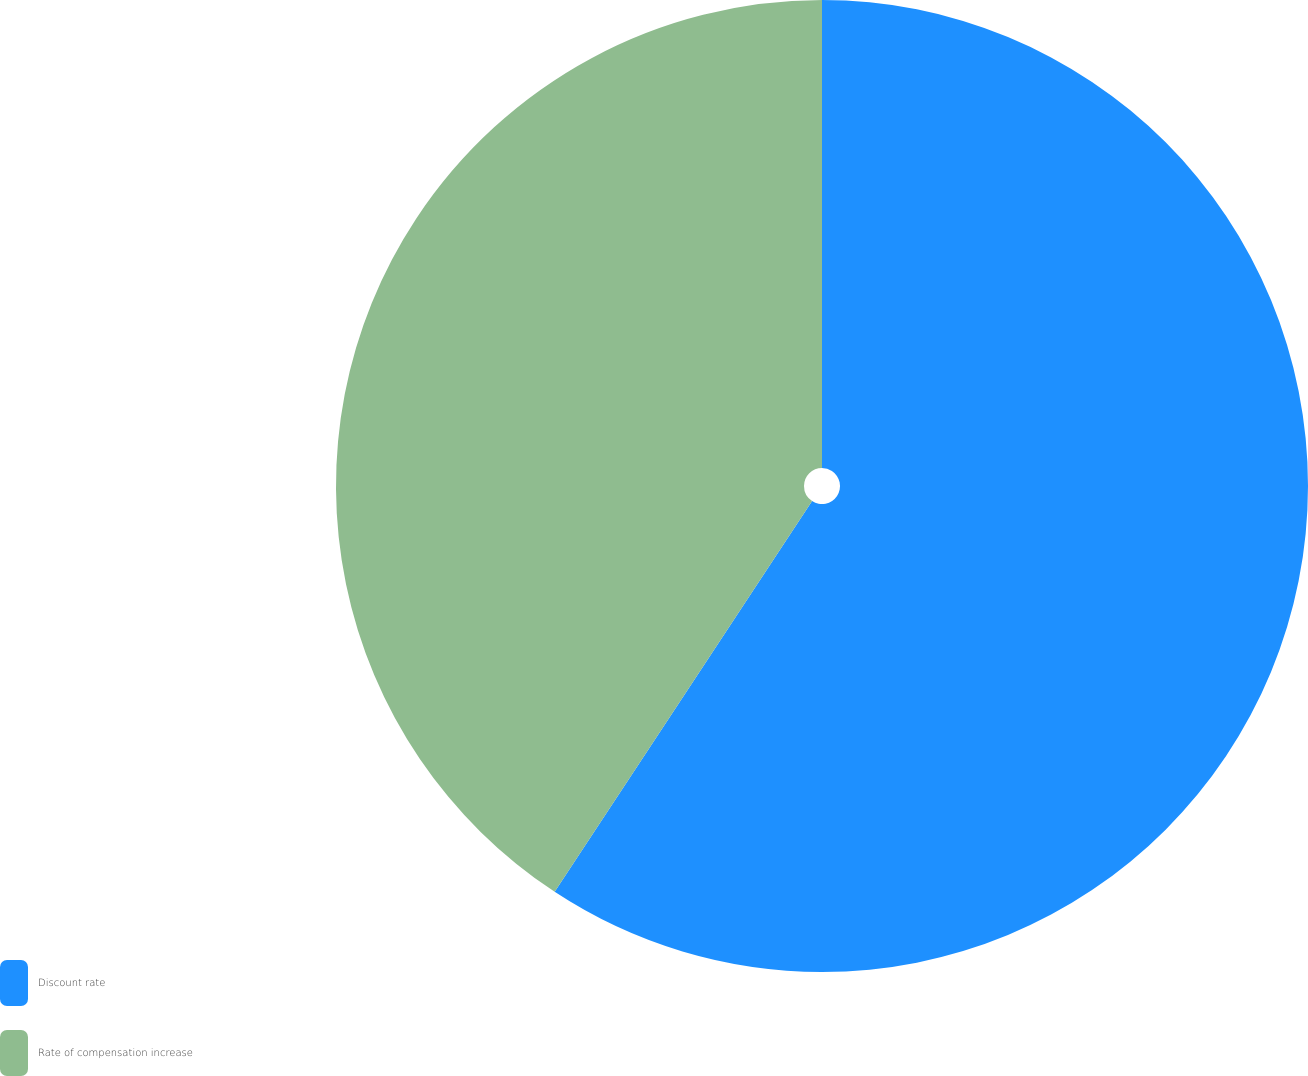<chart> <loc_0><loc_0><loc_500><loc_500><pie_chart><fcel>Discount rate<fcel>Rate of compensation increase<nl><fcel>59.27%<fcel>40.73%<nl></chart> 